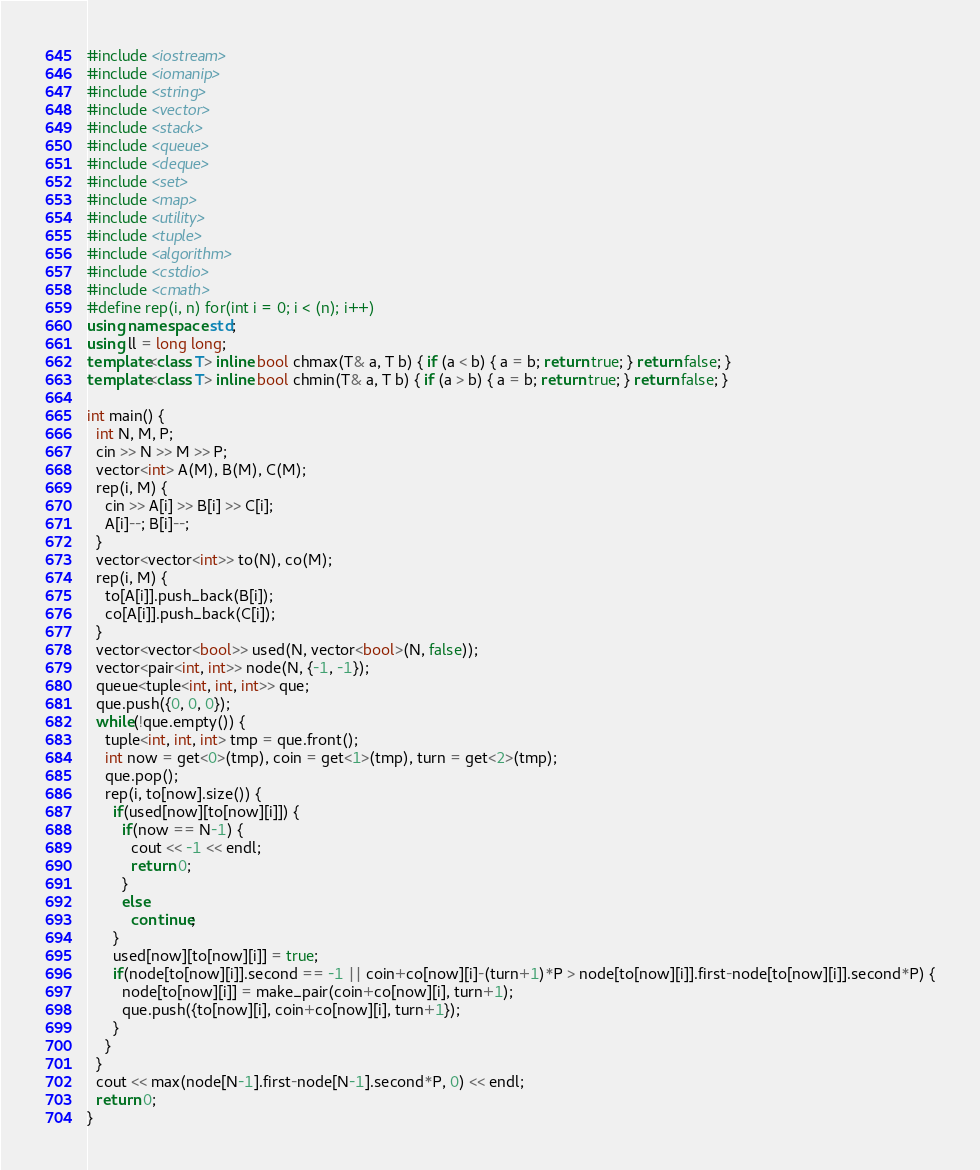<code> <loc_0><loc_0><loc_500><loc_500><_C++_>#include <iostream>
#include <iomanip>
#include <string>
#include <vector>
#include <stack>
#include <queue>
#include <deque>
#include <set>
#include <map>
#include <utility>
#include <tuple>
#include <algorithm>
#include <cstdio>
#include <cmath>
#define rep(i, n) for(int i = 0; i < (n); i++)
using namespace std;
using ll = long long;
template<class T> inline bool chmax(T& a, T b) { if (a < b) { a = b; return true; } return false; }
template<class T> inline bool chmin(T& a, T b) { if (a > b) { a = b; return true; } return false; }

int main() {
  int N, M, P;
  cin >> N >> M >> P;
  vector<int> A(M), B(M), C(M);
  rep(i, M) {
    cin >> A[i] >> B[i] >> C[i];
    A[i]--; B[i]--;
  }
  vector<vector<int>> to(N), co(M);
  rep(i, M) {
    to[A[i]].push_back(B[i]);
    co[A[i]].push_back(C[i]);
  }
  vector<vector<bool>> used(N, vector<bool>(N, false));
  vector<pair<int, int>> node(N, {-1, -1});
  queue<tuple<int, int, int>> que;
  que.push({0, 0, 0});
  while(!que.empty()) {
    tuple<int, int, int> tmp = que.front();
    int now = get<0>(tmp), coin = get<1>(tmp), turn = get<2>(tmp);
    que.pop();
    rep(i, to[now].size()) {
      if(used[now][to[now][i]]) {
        if(now == N-1) {
          cout << -1 << endl;
          return 0;
        }
        else
          continue;
      }
      used[now][to[now][i]] = true;
      if(node[to[now][i]].second == -1 || coin+co[now][i]-(turn+1)*P > node[to[now][i]].first-node[to[now][i]].second*P) {
        node[to[now][i]] = make_pair(coin+co[now][i], turn+1);
        que.push({to[now][i], coin+co[now][i], turn+1});
      }
    }
  }
  cout << max(node[N-1].first-node[N-1].second*P, 0) << endl;
  return 0;
}</code> 